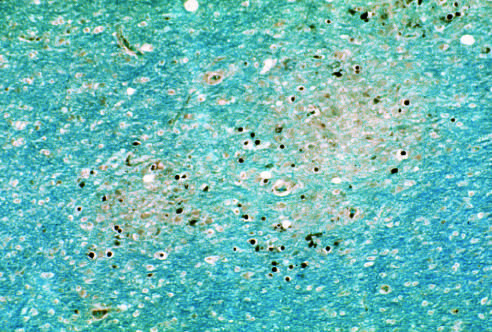do enlarged oligodendrocyte nuclei stained for viral antigens surround an area of early myelin loss?
Answer the question using a single word or phrase. Yes 